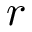<formula> <loc_0><loc_0><loc_500><loc_500>r</formula> 